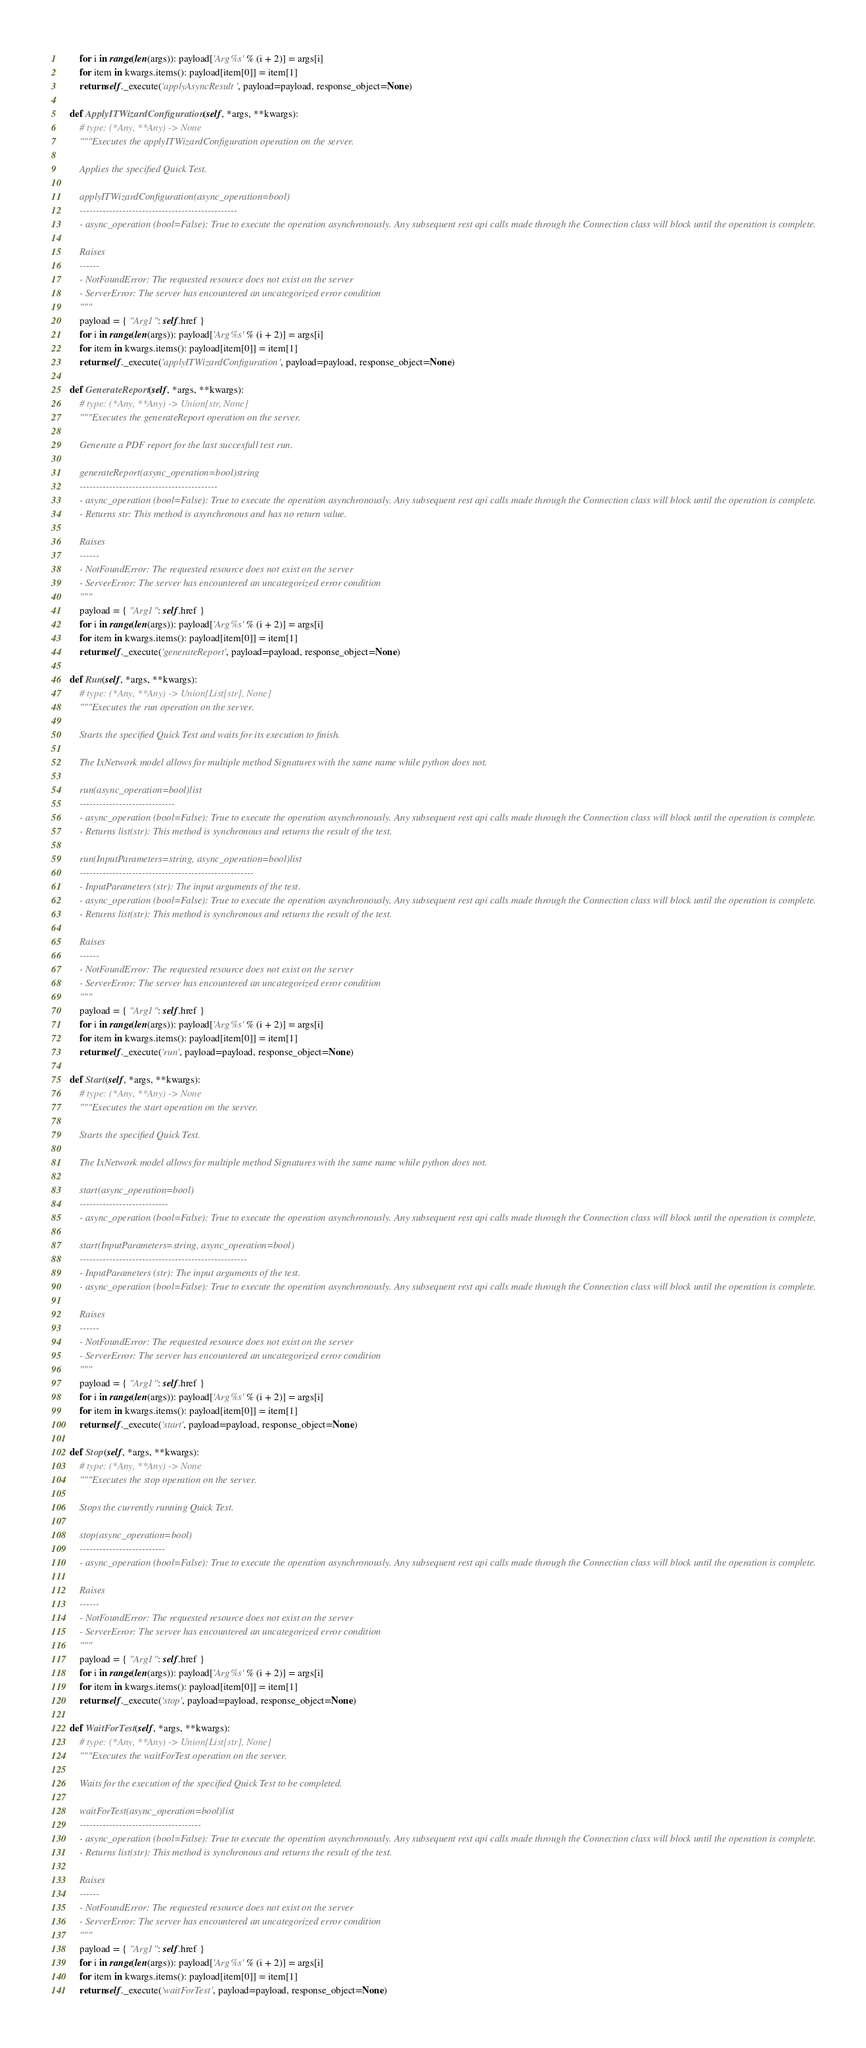Convert code to text. <code><loc_0><loc_0><loc_500><loc_500><_Python_>        for i in range(len(args)): payload['Arg%s' % (i + 2)] = args[i]
        for item in kwargs.items(): payload[item[0]] = item[1]
        return self._execute('applyAsyncResult', payload=payload, response_object=None)

    def ApplyITWizardConfiguration(self, *args, **kwargs):
        # type: (*Any, **Any) -> None
        """Executes the applyITWizardConfiguration operation on the server.

        Applies the specified Quick Test.

        applyITWizardConfiguration(async_operation=bool)
        ------------------------------------------------
        - async_operation (bool=False): True to execute the operation asynchronously. Any subsequent rest api calls made through the Connection class will block until the operation is complete.

        Raises
        ------
        - NotFoundError: The requested resource does not exist on the server
        - ServerError: The server has encountered an uncategorized error condition
        """
        payload = { "Arg1": self.href }
        for i in range(len(args)): payload['Arg%s' % (i + 2)] = args[i]
        for item in kwargs.items(): payload[item[0]] = item[1]
        return self._execute('applyITWizardConfiguration', payload=payload, response_object=None)

    def GenerateReport(self, *args, **kwargs):
        # type: (*Any, **Any) -> Union[str, None]
        """Executes the generateReport operation on the server.

        Generate a PDF report for the last succesfull test run.

        generateReport(async_operation=bool)string
        ------------------------------------------
        - async_operation (bool=False): True to execute the operation asynchronously. Any subsequent rest api calls made through the Connection class will block until the operation is complete.
        - Returns str: This method is asynchronous and has no return value.

        Raises
        ------
        - NotFoundError: The requested resource does not exist on the server
        - ServerError: The server has encountered an uncategorized error condition
        """
        payload = { "Arg1": self.href }
        for i in range(len(args)): payload['Arg%s' % (i + 2)] = args[i]
        for item in kwargs.items(): payload[item[0]] = item[1]
        return self._execute('generateReport', payload=payload, response_object=None)

    def Run(self, *args, **kwargs):
        # type: (*Any, **Any) -> Union[List[str], None]
        """Executes the run operation on the server.

        Starts the specified Quick Test and waits for its execution to finish.

        The IxNetwork model allows for multiple method Signatures with the same name while python does not.

        run(async_operation=bool)list
        -----------------------------
        - async_operation (bool=False): True to execute the operation asynchronously. Any subsequent rest api calls made through the Connection class will block until the operation is complete.
        - Returns list(str): This method is synchronous and returns the result of the test.

        run(InputParameters=string, async_operation=bool)list
        -----------------------------------------------------
        - InputParameters (str): The input arguments of the test.
        - async_operation (bool=False): True to execute the operation asynchronously. Any subsequent rest api calls made through the Connection class will block until the operation is complete.
        - Returns list(str): This method is synchronous and returns the result of the test.

        Raises
        ------
        - NotFoundError: The requested resource does not exist on the server
        - ServerError: The server has encountered an uncategorized error condition
        """
        payload = { "Arg1": self.href }
        for i in range(len(args)): payload['Arg%s' % (i + 2)] = args[i]
        for item in kwargs.items(): payload[item[0]] = item[1]
        return self._execute('run', payload=payload, response_object=None)

    def Start(self, *args, **kwargs):
        # type: (*Any, **Any) -> None
        """Executes the start operation on the server.

        Starts the specified Quick Test.

        The IxNetwork model allows for multiple method Signatures with the same name while python does not.

        start(async_operation=bool)
        ---------------------------
        - async_operation (bool=False): True to execute the operation asynchronously. Any subsequent rest api calls made through the Connection class will block until the operation is complete.

        start(InputParameters=string, async_operation=bool)
        ---------------------------------------------------
        - InputParameters (str): The input arguments of the test.
        - async_operation (bool=False): True to execute the operation asynchronously. Any subsequent rest api calls made through the Connection class will block until the operation is complete.

        Raises
        ------
        - NotFoundError: The requested resource does not exist on the server
        - ServerError: The server has encountered an uncategorized error condition
        """
        payload = { "Arg1": self.href }
        for i in range(len(args)): payload['Arg%s' % (i + 2)] = args[i]
        for item in kwargs.items(): payload[item[0]] = item[1]
        return self._execute('start', payload=payload, response_object=None)

    def Stop(self, *args, **kwargs):
        # type: (*Any, **Any) -> None
        """Executes the stop operation on the server.

        Stops the currently running Quick Test.

        stop(async_operation=bool)
        --------------------------
        - async_operation (bool=False): True to execute the operation asynchronously. Any subsequent rest api calls made through the Connection class will block until the operation is complete.

        Raises
        ------
        - NotFoundError: The requested resource does not exist on the server
        - ServerError: The server has encountered an uncategorized error condition
        """
        payload = { "Arg1": self.href }
        for i in range(len(args)): payload['Arg%s' % (i + 2)] = args[i]
        for item in kwargs.items(): payload[item[0]] = item[1]
        return self._execute('stop', payload=payload, response_object=None)

    def WaitForTest(self, *args, **kwargs):
        # type: (*Any, **Any) -> Union[List[str], None]
        """Executes the waitForTest operation on the server.

        Waits for the execution of the specified Quick Test to be completed.

        waitForTest(async_operation=bool)list
        -------------------------------------
        - async_operation (bool=False): True to execute the operation asynchronously. Any subsequent rest api calls made through the Connection class will block until the operation is complete.
        - Returns list(str): This method is synchronous and returns the result of the test.

        Raises
        ------
        - NotFoundError: The requested resource does not exist on the server
        - ServerError: The server has encountered an uncategorized error condition
        """
        payload = { "Arg1": self.href }
        for i in range(len(args)): payload['Arg%s' % (i + 2)] = args[i]
        for item in kwargs.items(): payload[item[0]] = item[1]
        return self._execute('waitForTest', payload=payload, response_object=None)
</code> 